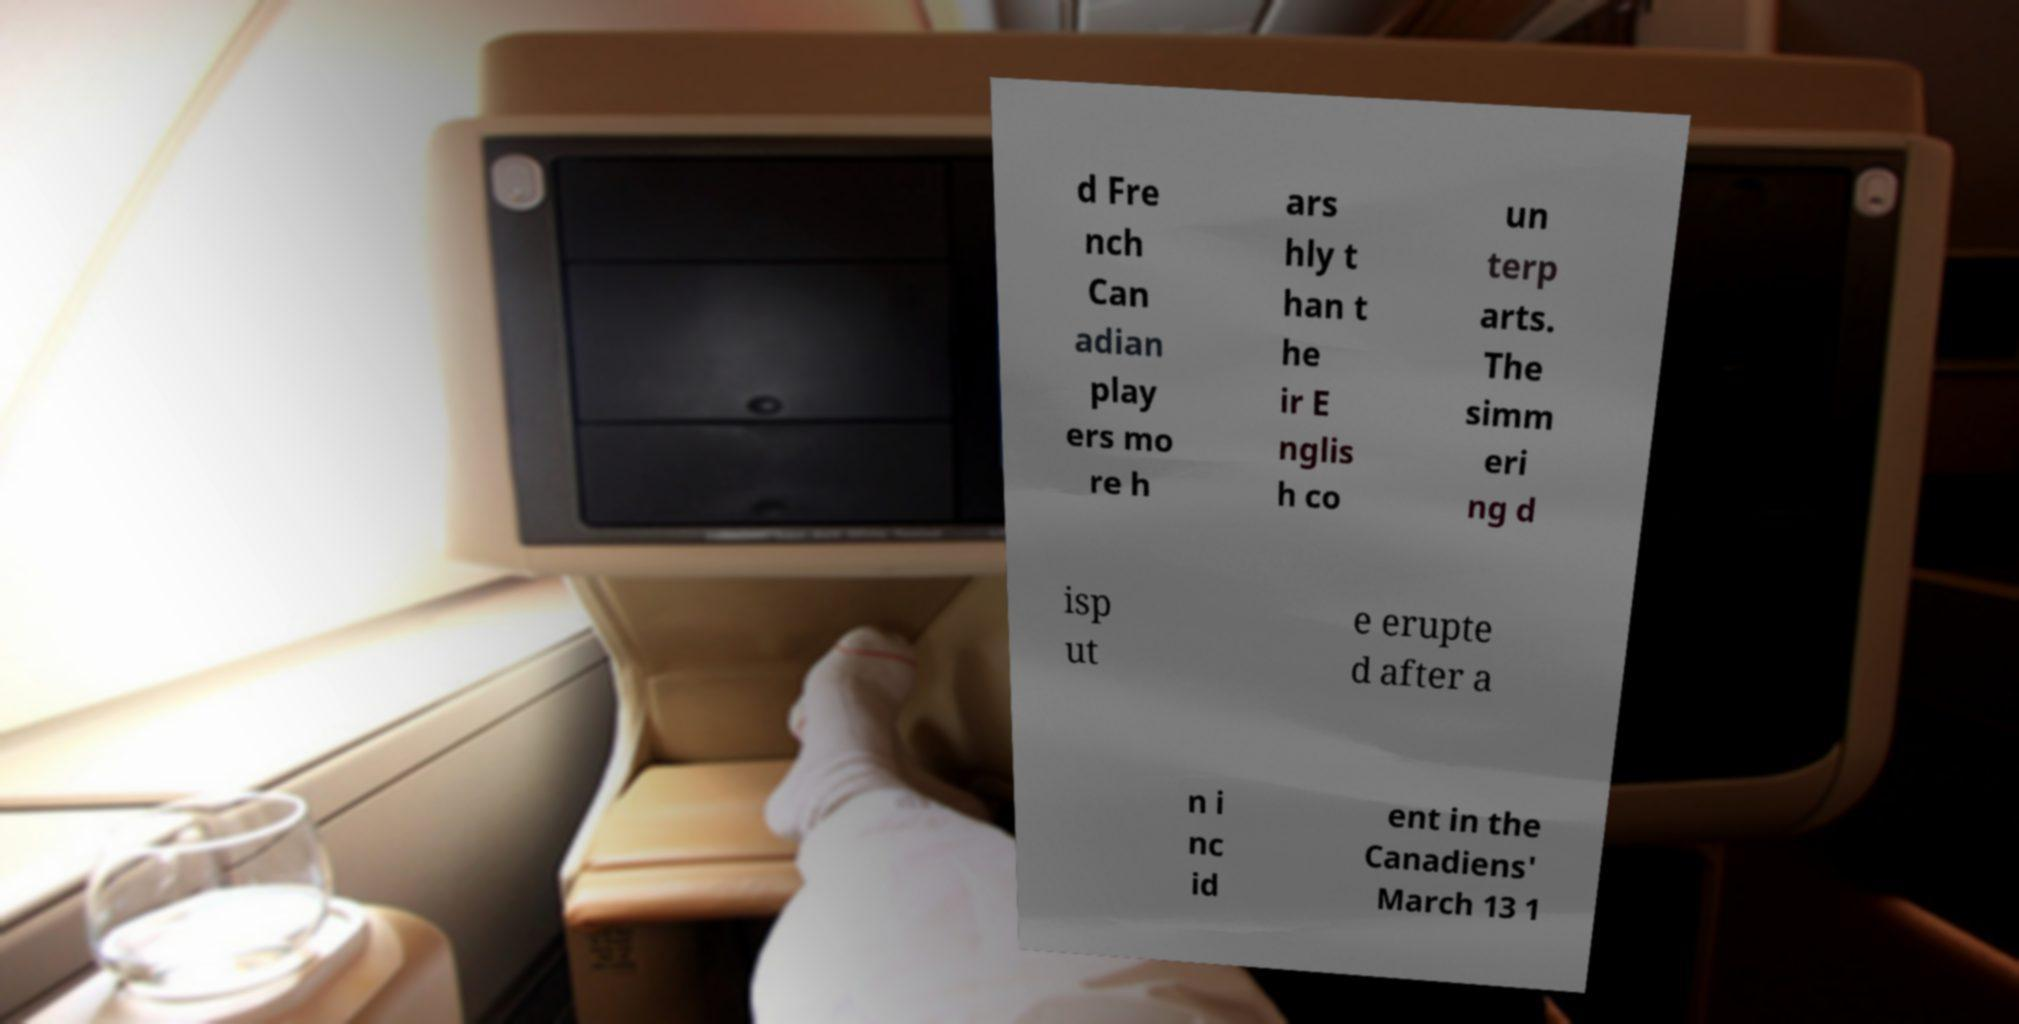Can you read and provide the text displayed in the image?This photo seems to have some interesting text. Can you extract and type it out for me? d Fre nch Can adian play ers mo re h ars hly t han t he ir E nglis h co un terp arts. The simm eri ng d isp ut e erupte d after a n i nc id ent in the Canadiens' March 13 1 